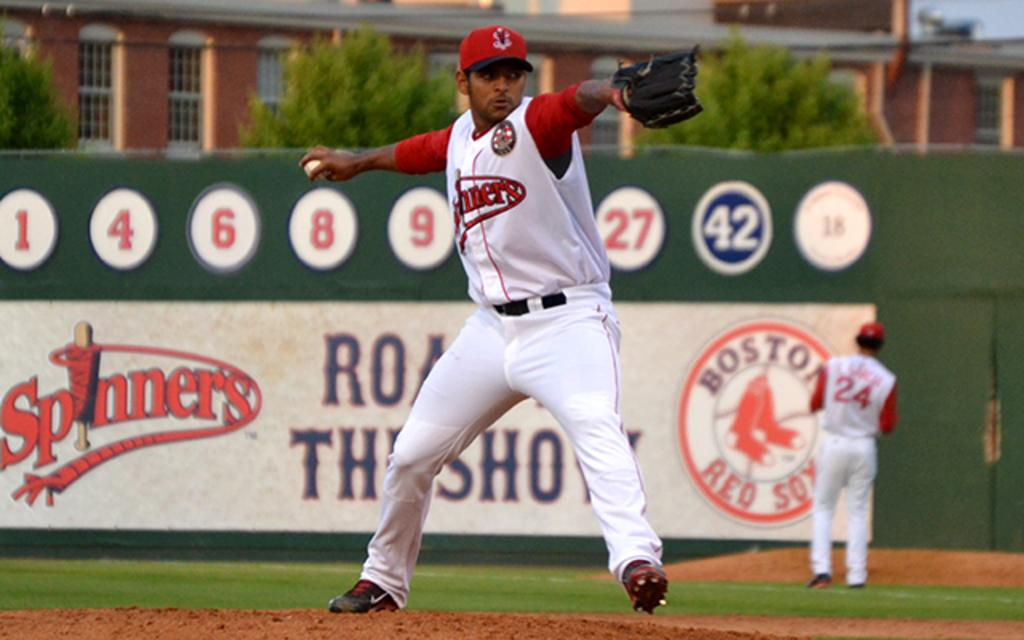<image>
Offer a succinct explanation of the picture presented. A billboard that says Spinners and Boston Redsox 